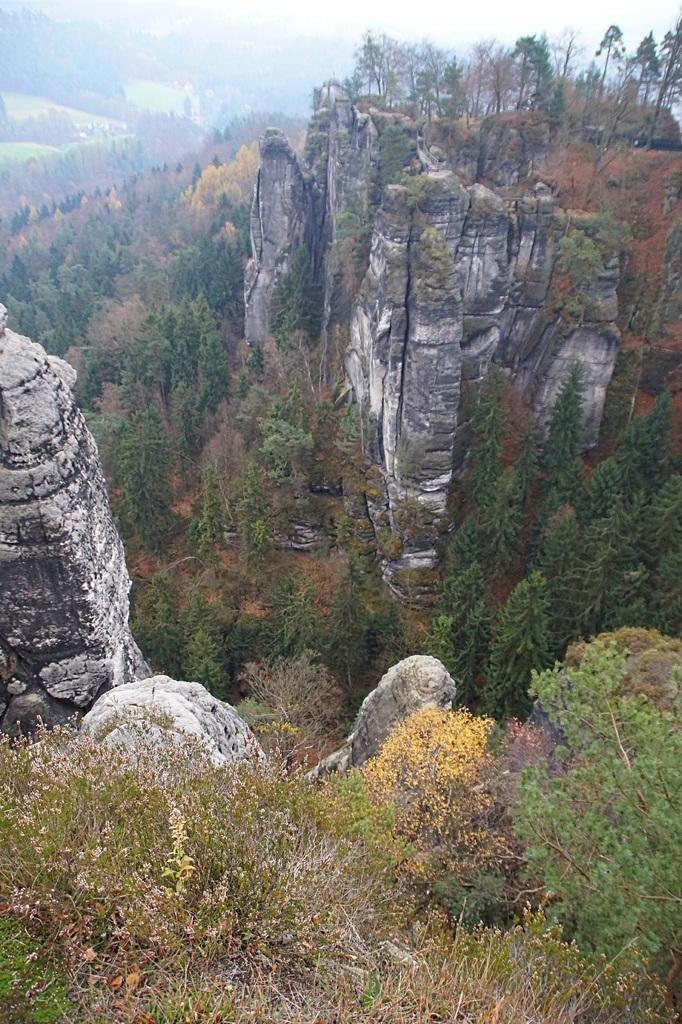What type of natural formation can be seen in the image? There are mountains in the image. What colors are the plants in the image? The plants in the image are green and yellow. What is visible in the background of the image? There are mountains, trees, and the sky visible in the background of the image. What month is it in the image? The month cannot be determined from the image, as it does not contain any information about the time of year. 